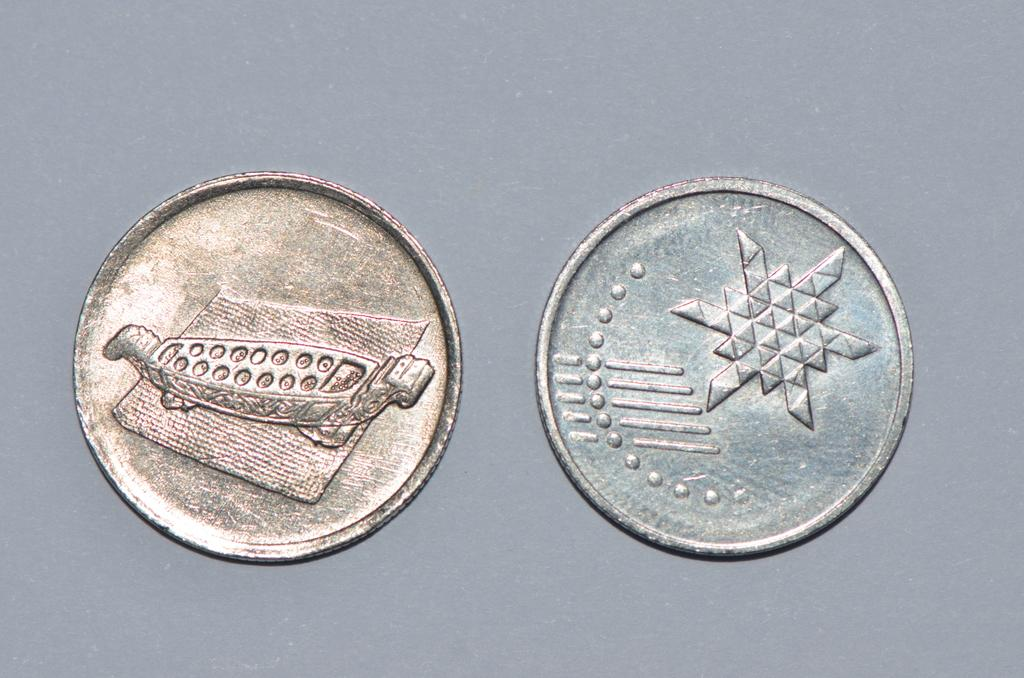What objects can be seen in the image? There are coins in the image. Can you describe the appearance of the coins? The provided facts do not include a description of the coins' appearance. How many coins are visible in the image? The provided facts do not specify the number of coins in the image. What type of holiday is being celebrated in the image? There is no holiday depicted in the image; it only features coins. Can you describe the field where the protest is taking place in the image? There is no field or protest present in the image; it only features coins. 